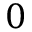<formula> <loc_0><loc_0><loc_500><loc_500>0</formula> 